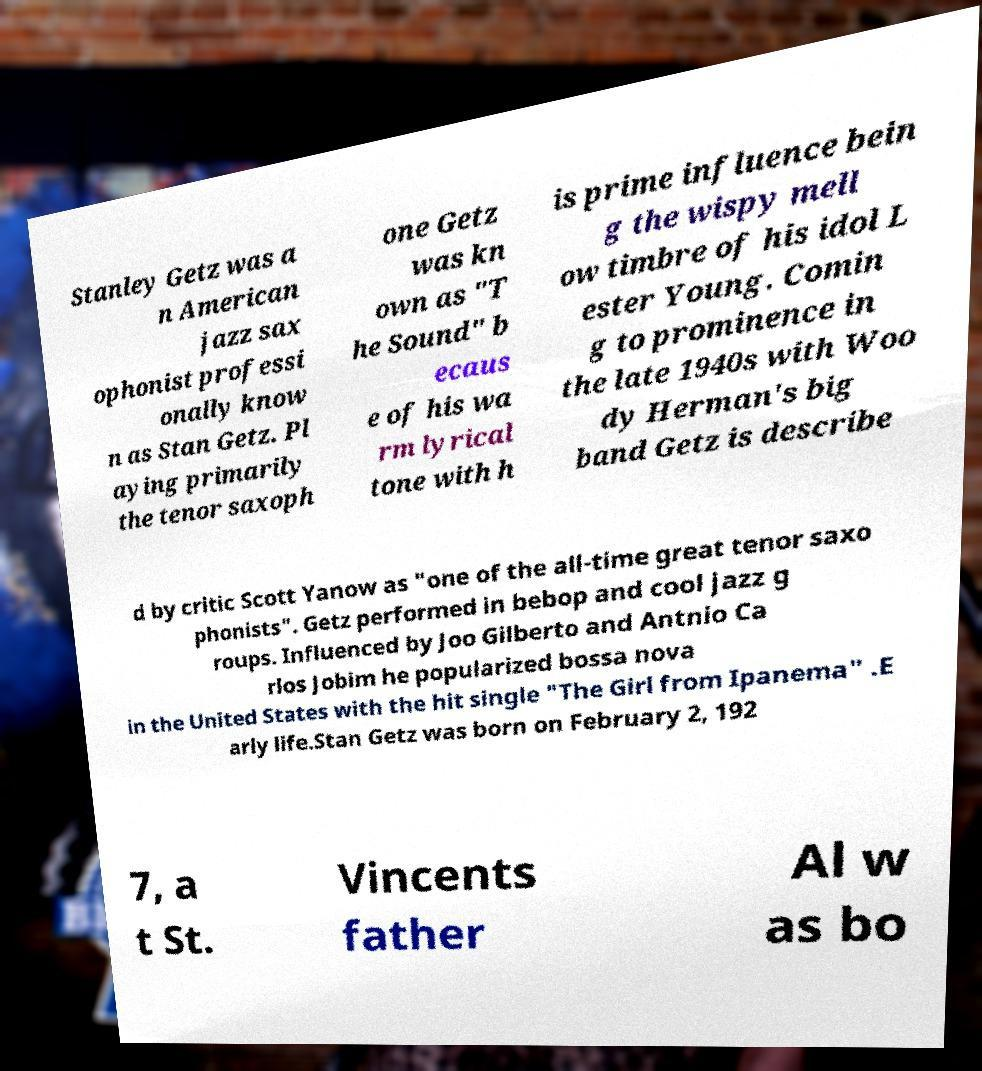Can you read and provide the text displayed in the image?This photo seems to have some interesting text. Can you extract and type it out for me? Stanley Getz was a n American jazz sax ophonist professi onally know n as Stan Getz. Pl aying primarily the tenor saxoph one Getz was kn own as "T he Sound" b ecaus e of his wa rm lyrical tone with h is prime influence bein g the wispy mell ow timbre of his idol L ester Young. Comin g to prominence in the late 1940s with Woo dy Herman's big band Getz is describe d by critic Scott Yanow as "one of the all-time great tenor saxo phonists". Getz performed in bebop and cool jazz g roups. Influenced by Joo Gilberto and Antnio Ca rlos Jobim he popularized bossa nova in the United States with the hit single "The Girl from Ipanema" .E arly life.Stan Getz was born on February 2, 192 7, a t St. Vincents father Al w as bo 